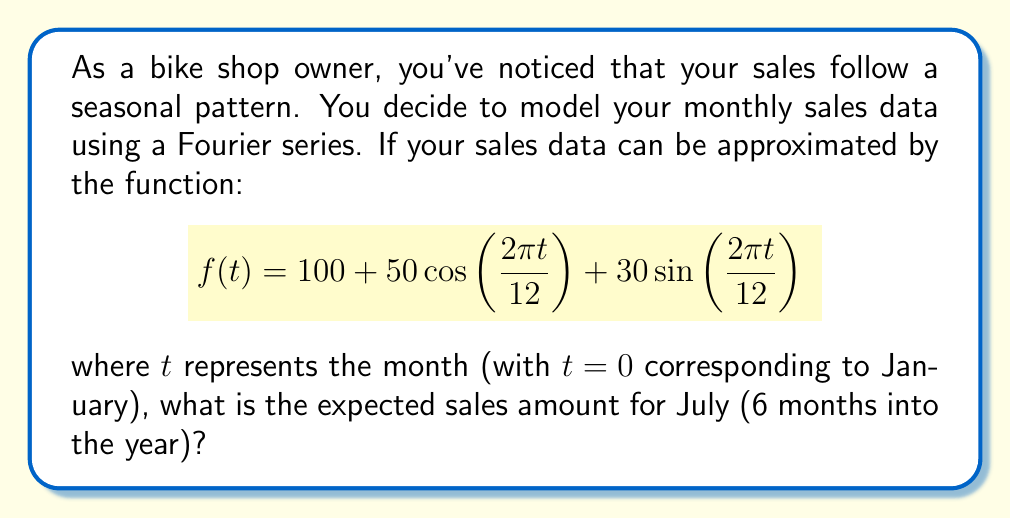Show me your answer to this math problem. To solve this problem, we need to follow these steps:

1) First, we identify that July corresponds to $t=6$ in our model, as it's 6 months into the year.

2) We then substitute $t=6$ into our Fourier series function:

   $$f(6) = 100 + 50\cos\left(\frac{2\pi \cdot 6}{12}\right) + 30\sin\left(\frac{2\pi \cdot 6}{12}\right)$$

3) Simplify the arguments of the trigonometric functions:

   $$f(6) = 100 + 50\cos(\pi) + 30\sin(\pi)$$

4) Evaluate the trigonometric functions:
   - $\cos(\pi) = -1$
   - $\sin(\pi) = 0$

5) Substitute these values:

   $$f(6) = 100 + 50(-1) + 30(0)$$

6) Simplify:

   $$f(6) = 100 - 50 + 0 = 50$$

Therefore, the expected sales amount for July is 50 units.
Answer: 50 units 